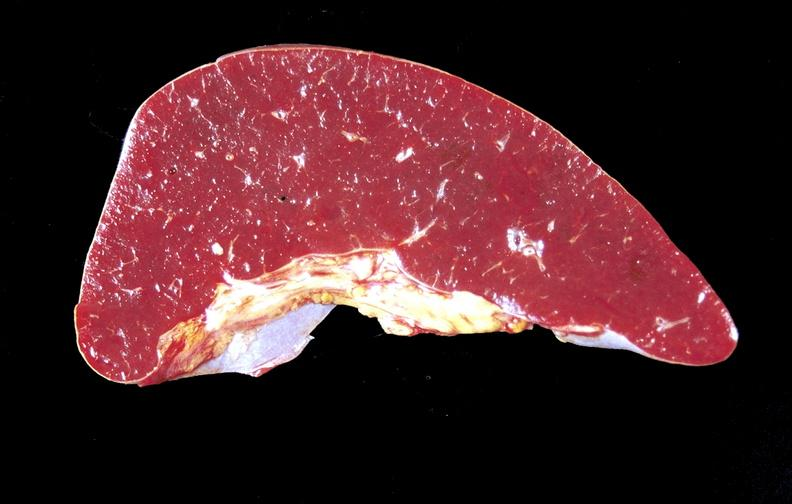s purulent sinusitis present?
Answer the question using a single word or phrase. No 